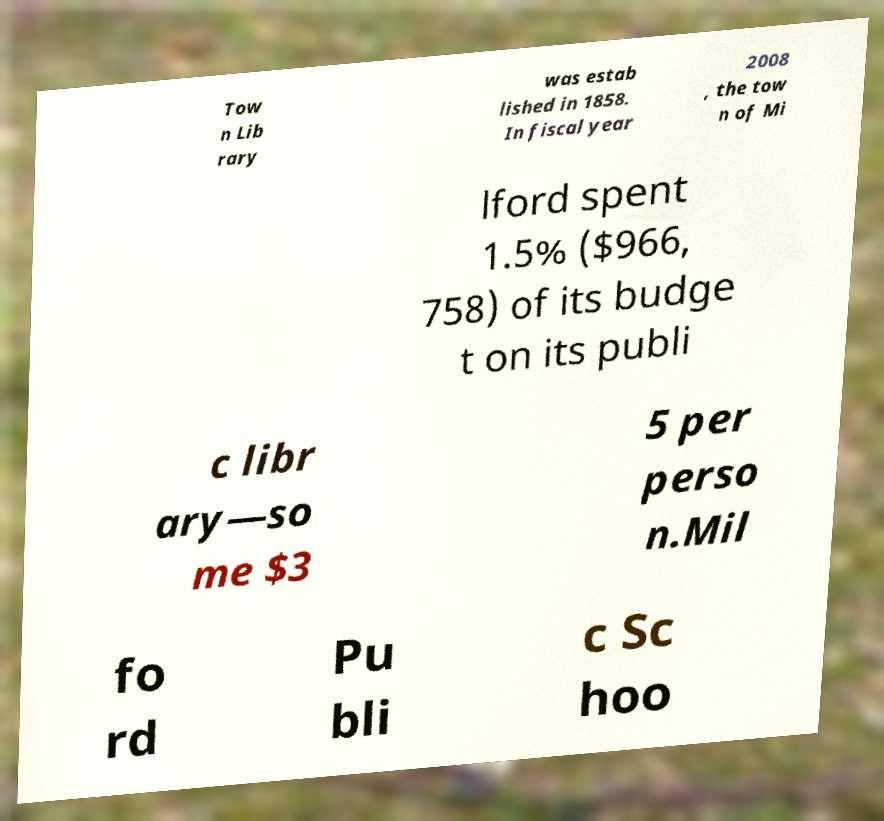Please identify and transcribe the text found in this image. Tow n Lib rary was estab lished in 1858. In fiscal year 2008 , the tow n of Mi lford spent 1.5% ($966, 758) of its budge t on its publi c libr ary—so me $3 5 per perso n.Mil fo rd Pu bli c Sc hoo 